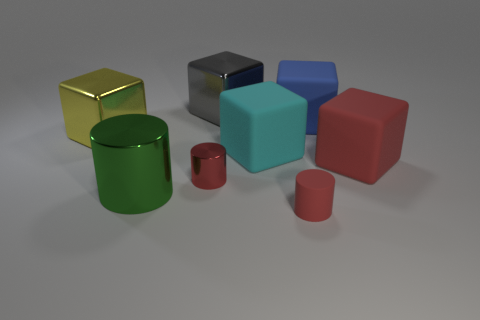How many other things are the same material as the large cyan cube?
Keep it short and to the point. 3. What number of objects are either big metal objects that are behind the yellow shiny block or big cyan rubber spheres?
Provide a short and direct response. 1. There is a big matte thing behind the big cube on the left side of the gray block; what shape is it?
Offer a terse response. Cube. There is a rubber thing behind the cyan matte object; does it have the same shape as the yellow shiny thing?
Provide a succinct answer. Yes. There is a metallic object that is right of the tiny red shiny cylinder; what is its color?
Offer a very short reply. Gray. What number of cubes are tiny gray rubber objects or yellow metallic objects?
Give a very brief answer. 1. There is a blue object that is on the right side of the small red thing in front of the red metal object; how big is it?
Ensure brevity in your answer.  Large. There is a tiny rubber cylinder; does it have the same color as the tiny cylinder behind the large cylinder?
Your response must be concise. Yes. How many big blocks are to the left of the large red matte block?
Provide a succinct answer. 4. Is the number of small red matte cylinders less than the number of metal cylinders?
Give a very brief answer. Yes. 